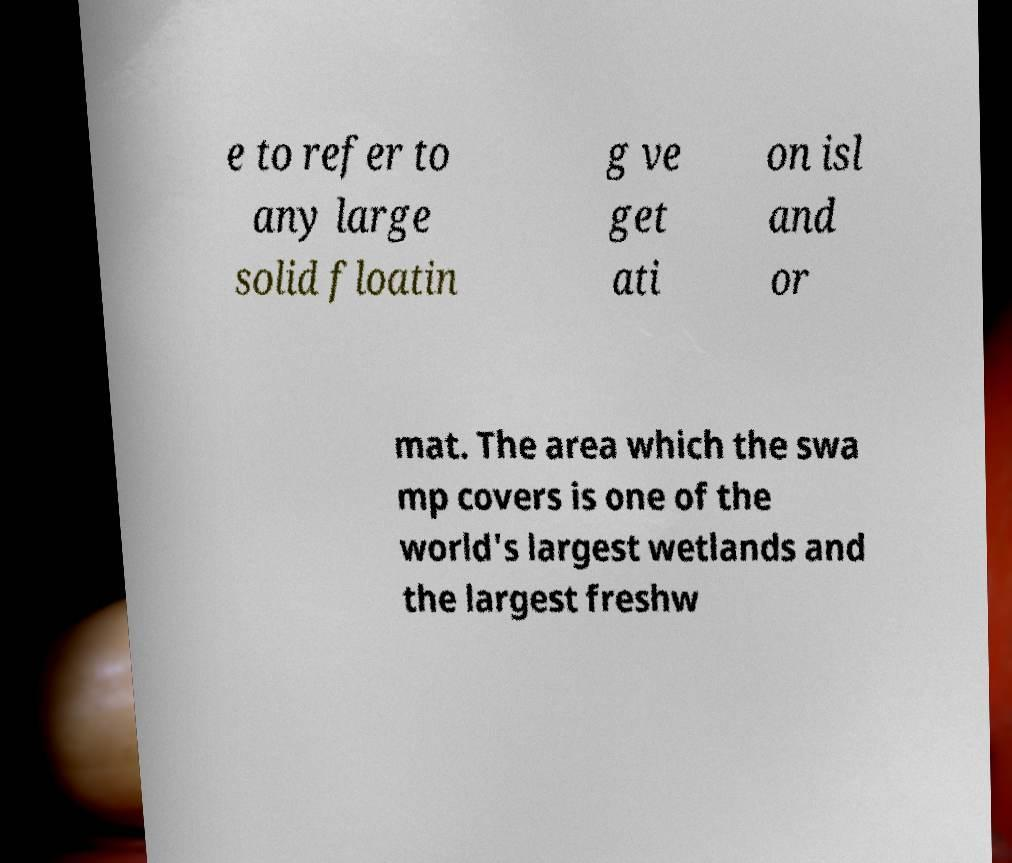I need the written content from this picture converted into text. Can you do that? e to refer to any large solid floatin g ve get ati on isl and or mat. The area which the swa mp covers is one of the world's largest wetlands and the largest freshw 